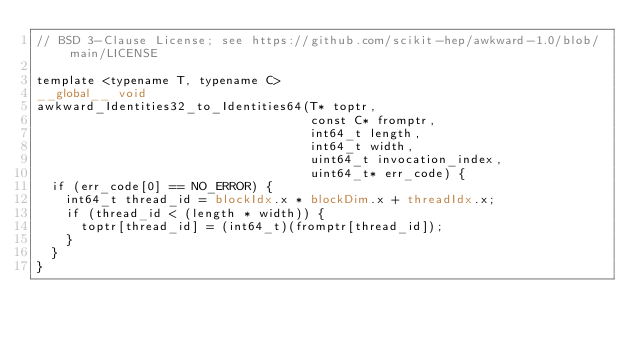<code> <loc_0><loc_0><loc_500><loc_500><_Cuda_>// BSD 3-Clause License; see https://github.com/scikit-hep/awkward-1.0/blob/main/LICENSE

template <typename T, typename C>
__global__ void
awkward_Identities32_to_Identities64(T* toptr,
                                     const C* fromptr,
                                     int64_t length,
                                     int64_t width,
                                     uint64_t invocation_index,
                                     uint64_t* err_code) {
  if (err_code[0] == NO_ERROR) {
    int64_t thread_id = blockIdx.x * blockDim.x + threadIdx.x;
    if (thread_id < (length * width)) {
      toptr[thread_id] = (int64_t)(fromptr[thread_id]);
    }
  }
}
</code> 